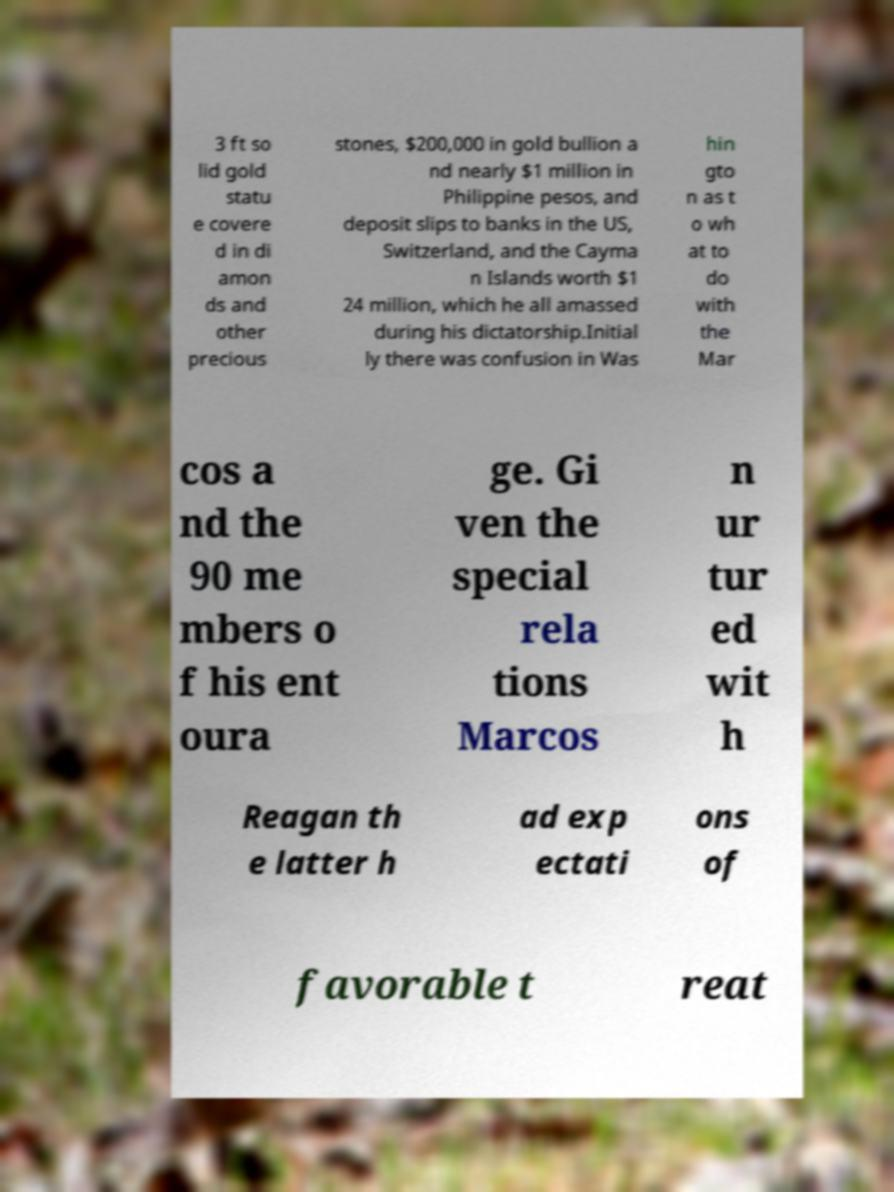What messages or text are displayed in this image? I need them in a readable, typed format. 3 ft so lid gold statu e covere d in di amon ds and other precious stones, $200,000 in gold bullion a nd nearly $1 million in Philippine pesos, and deposit slips to banks in the US, Switzerland, and the Cayma n Islands worth $1 24 million, which he all amassed during his dictatorship.Initial ly there was confusion in Was hin gto n as t o wh at to do with the Mar cos a nd the 90 me mbers o f his ent oura ge. Gi ven the special rela tions Marcos n ur tur ed wit h Reagan th e latter h ad exp ectati ons of favorable t reat 